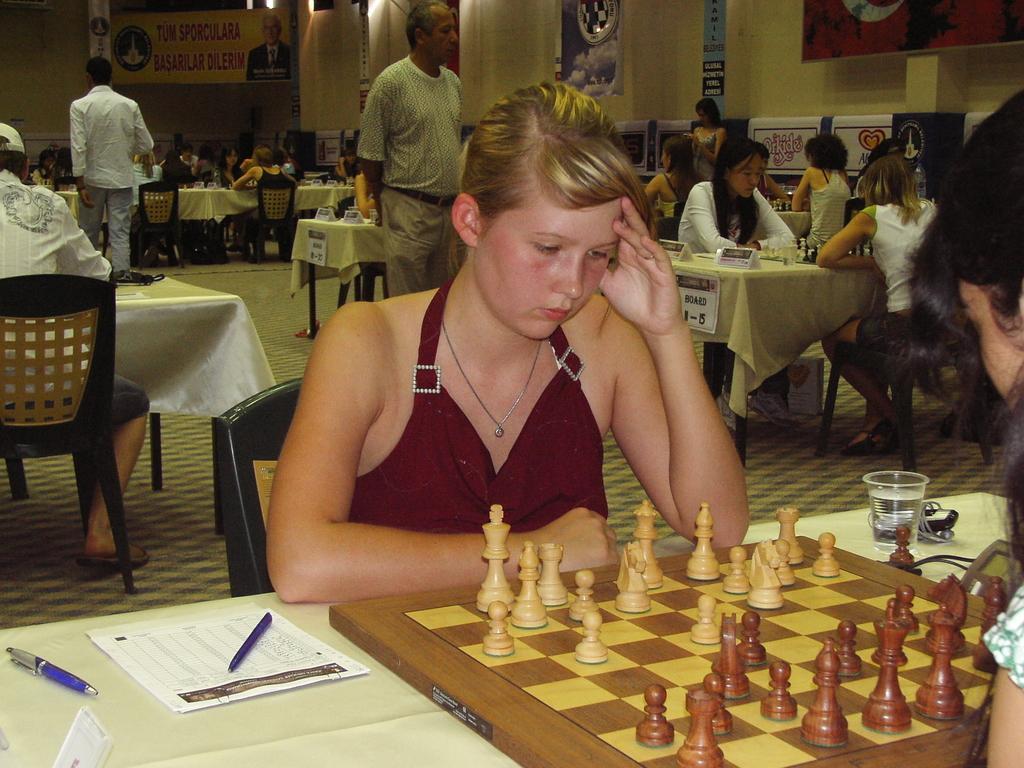In one or two sentences, can you explain what this image depicts? People are sitting on the the chair near the table and on the table this is chess board,bottle,glass,pen,paper and here there is poster. 